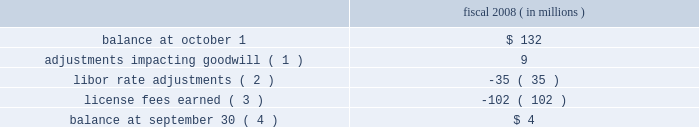Visa inc .
Notes to consolidated financial statements 2014 ( continued ) september 30 , 2008 ( in millions , except as noted ) trademark and technology licenses visa inc. , visa u.s.a. , visa international and inovant , as licensors , granted to visa europe exclusive , irrevocable and perpetual licenses to use the visa trademarks and technology intellectual property owned by the licensors and certain affiliates within the visa europe region for use in the field of financial services , payments , related information technology and information processing services and participation in the visa system .
Visa europe may sublicense the visa trademarks and technology intellectual property to its members and other sublicensees , such as processors , for use within visa europe 2019s region and , in certain limited circumstances , outside the visa europe region .
The fee payable for these irrevocable and perpetual licenses is approximately $ 143 million per year , payable quarterly , which is referred to as the quarterly base fee , except for the year ended september 30 , 2008 during which the fee payable was $ 41 million .
The reduced payment for 2008 was calculated based on applying the three-month libor rate plus 100 to 200 basis points to $ 1.146 billion and certain results of the ipo .
Beginning november 9 , 2010 the quarterly base fee will be increased annually based on the annual growth of the gross domestic product of the european union .
The company determined through an analysis of the fee rates implied by the economics of the agreement that the quarterly base fee , as adjusted in future periods based on the growth of the gross domestic product of the european union , approximates fair value .
As a result of the approximately $ 102 million reduction in payment for the year ended september 30 , 2008 , the trademark and technology license agreement represents a contract that is below fair value .
Calculation of liability under the framework agreement at october 1 , 2007 , the company recorded a liability of approximately $ 132 million to reflect the company 2019s estimated obligation to provide these licenses at below fair value .
The application of the libor rate in determining the reduced payment represents a variable interest element embedded within the framework agreement , which the company has treated as an embedded derivative with changes in fair value reflected in visa inc . 2019s consolidated statement of operations under the guidelines of sfas 133 .
During the year ended september 30 , 2008 , the company made adjustments to its liability under the framework agreement as follows : fiscal 2008 ( in millions ) .
Adjustments impacting goodwill ( 1 ) .
9 libor rate adjustments ( 2 ) .
( 35 ) license fees earned ( 3 ) .
( 102 ) balance at september 30 ( 4 ) .
$ 4 ( 1 ) the company made adjustments to the calculation of its liability of : ( i ) $ 2 million to reflect a minor adjustment to the calculation methodology ; ( ii ) $ 5 million to update the liability to reflect actual ipo assumptions and ( iii ) $ 2 million to reflect the change of redemption date. .
What is the net change in liability for the fiscal year 2008? 
Computations: (4 - 132)
Answer: -128.0. 